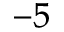<formula> <loc_0><loc_0><loc_500><loc_500>^ { - 5 }</formula> 